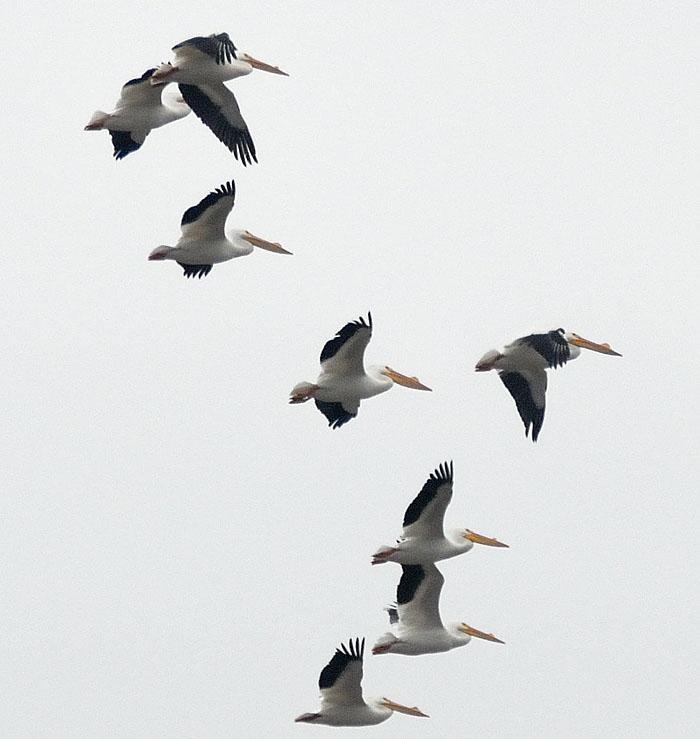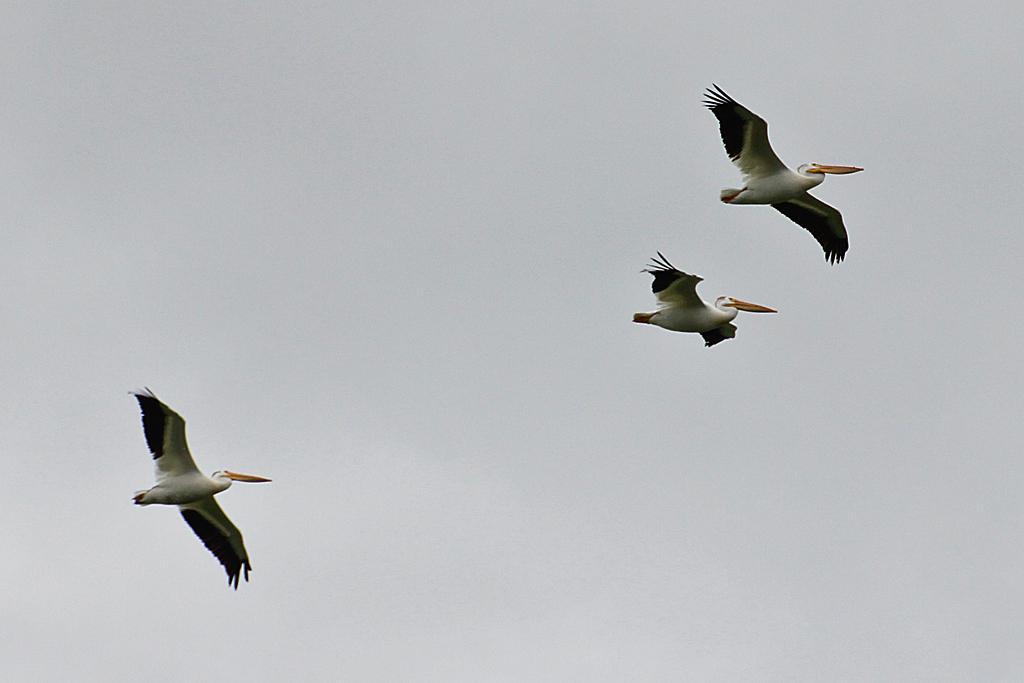The first image is the image on the left, the second image is the image on the right. For the images displayed, is the sentence "One image contains less than 5 flying birds." factually correct? Answer yes or no. Yes. 